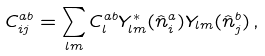Convert formula to latex. <formula><loc_0><loc_0><loc_500><loc_500>C ^ { a b } _ { i j } = \sum _ { l m } C ^ { a b } _ { l } Y _ { l m } ^ { * } ( \hat { n } _ { i } ^ { a } ) Y _ { l m } ( \hat { n } _ { j } ^ { b } ) \, ,</formula> 